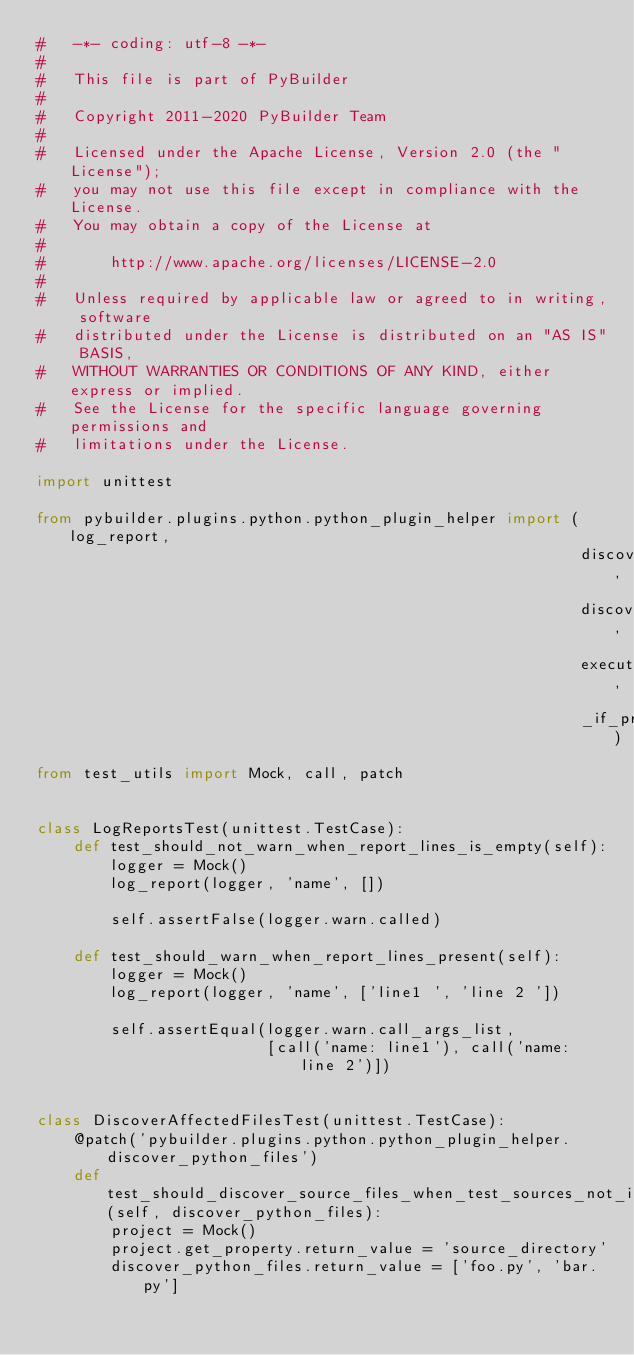<code> <loc_0><loc_0><loc_500><loc_500><_Python_>#   -*- coding: utf-8 -*-
#
#   This file is part of PyBuilder
#
#   Copyright 2011-2020 PyBuilder Team
#
#   Licensed under the Apache License, Version 2.0 (the "License");
#   you may not use this file except in compliance with the License.
#   You may obtain a copy of the License at
#
#       http://www.apache.org/licenses/LICENSE-2.0
#
#   Unless required by applicable law or agreed to in writing, software
#   distributed under the License is distributed on an "AS IS" BASIS,
#   WITHOUT WARRANTIES OR CONDITIONS OF ANY KIND, either express or implied.
#   See the License for the specific language governing permissions and
#   limitations under the License.

import unittest

from pybuilder.plugins.python.python_plugin_helper import (log_report,
                                                           discover_affected_files,
                                                           discover_affected_dirs,
                                                           execute_tool_on_source_files,
                                                           _if_property_set_and_dir_exists)
from test_utils import Mock, call, patch


class LogReportsTest(unittest.TestCase):
    def test_should_not_warn_when_report_lines_is_empty(self):
        logger = Mock()
        log_report(logger, 'name', [])

        self.assertFalse(logger.warn.called)

    def test_should_warn_when_report_lines_present(self):
        logger = Mock()
        log_report(logger, 'name', ['line1 ', 'line 2 '])

        self.assertEqual(logger.warn.call_args_list,
                         [call('name: line1'), call('name: line 2')])


class DiscoverAffectedFilesTest(unittest.TestCase):
    @patch('pybuilder.plugins.python.python_plugin_helper.discover_python_files')
    def test_should_discover_source_files_when_test_sources_not_included(self, discover_python_files):
        project = Mock()
        project.get_property.return_value = 'source_directory'
        discover_python_files.return_value = ['foo.py', 'bar.py']
</code> 